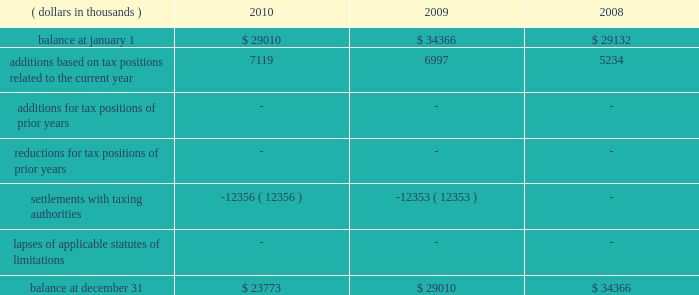A reconciliation of the beginning and ending amount of unrecognized tax benefits , for the periods indicated , is as follows: .
The entire amount of the unrecognized tax benefits would affect the effective tax rate if recognized .
In 2010 , the company favorably settled a 2003 and 2004 irs audit .
The company recorded a net overall tax benefit including accrued interest of $ 25920 thousand .
In addition , the company was also able to take down a $ 12356 thousand fin 48 reserve that had been established regarding the 2003 and 2004 irs audit .
The company is no longer subject to u.s .
Federal , state and local or foreign income tax examinations by tax authorities for years before 2007 .
The company recognizes accrued interest related to net unrecognized tax benefits and penalties in income taxes .
During the years ended december 31 , 2010 , 2009 and 2008 , the company accrued and recognized a net expense ( benefit ) of approximately $ ( 9938 ) thousand , $ 1563 thousand and $ 2446 thousand , respectively , in interest and penalties .
Included within the 2010 net expense ( benefit ) of $ ( 9938 ) thousand is $ ( 10591 ) thousand of accrued interest related to the 2003 and 2004 irs audit .
The company is not aware of any positions for which it is reasonably possible that the total amounts of unrecognized tax benefits will significantly increase or decrease within twelve months of the reporting date .
For u.s .
Income tax purposes the company has foreign tax credit carryforwards of $ 55026 thousand that begin to expire in 2014 .
In addition , for u.s .
Income tax purposes the company has $ 41693 thousand of alternative minimum tax credits that do not expire .
Management believes that it is more likely than not that the company will realize the benefits of its net deferred tax assets and , accordingly , no valuation allowance has been recorded for the periods presented .
Tax benefits of $ 629 thousand and $ 1714 thousand related to share-based compensation deductions for stock options exercised in 2010 and 2009 , respectively , are included within additional paid-in capital of the shareholders 2019 equity section of the consolidated balance sheets. .
What was the total gross amount of money that the company received from their favorable audit? 
Rationale: the initial $ 12356 was added to the total due to them already subtracting that from expenses earlier . the next is unattributed money earned from investments . once added up the interest that was earned , you get $ 32885 .
Computations: ((12356 + 9938) + 10591)
Answer: 32885.0. 